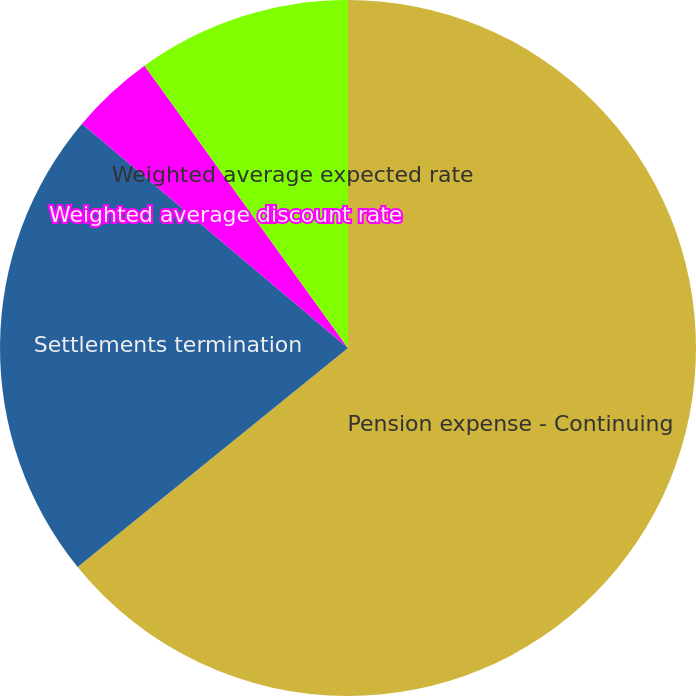Convert chart to OTSL. <chart><loc_0><loc_0><loc_500><loc_500><pie_chart><fcel>Pension expense - Continuing<fcel>Settlements termination<fcel>Weighted average discount rate<fcel>Weighted average expected rate<nl><fcel>64.17%<fcel>21.99%<fcel>3.91%<fcel>9.94%<nl></chart> 